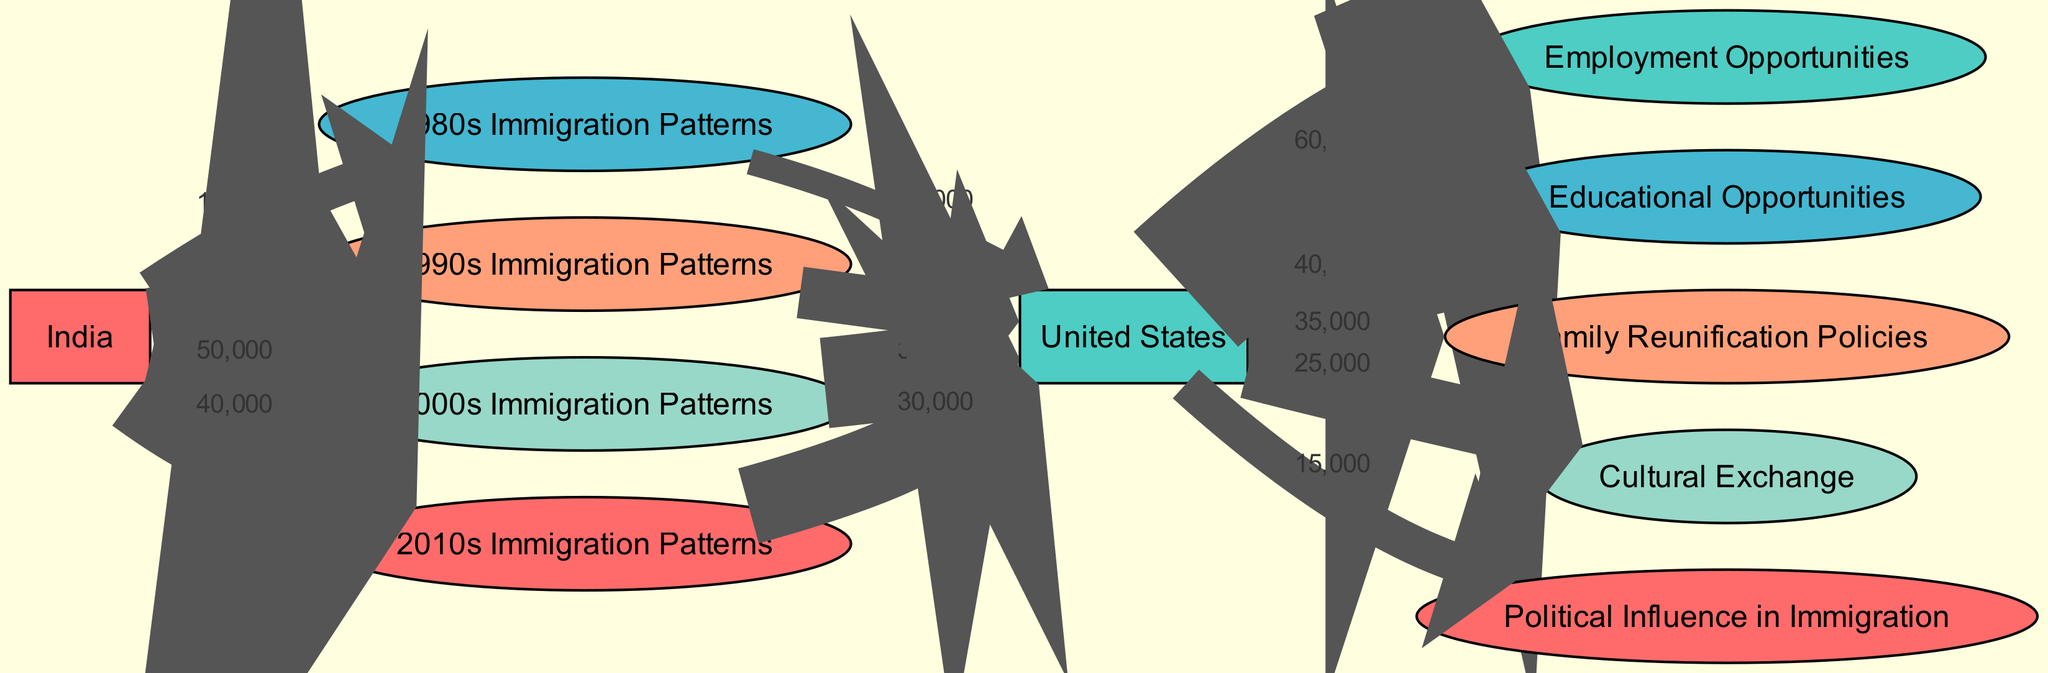What is the total number of immigrants from India in the 1990s? In the diagram, the flow from India to the 1990s Immigration Patterns node shows a value of 30,000. Thus, the total number of immigrants from India during the 1990s is derived directly from this value.
Answer: 30,000 What was the migration flow to the US from the 2000s? The flow from the 2000s Immigration Patterns node to the US node is represented by a value of 35,000. This indicates that 35,000 individuals migrated to the US from the 2000s cohort.
Answer: 35,000 Which immigration pattern had the highest flow to the US? By examining the connections to the US node, the 2000s Immigration Patterns shows a value of 35,000, which is the highest flow compared to the other immigration periods (1980s: 10,000; 1990s: 20,000; 2010s: 30,000).
Answer: 2000s Immigration Patterns What percentage of the total immigration from India in the 2000s successfully settled in the US? To find the percentage, divide the flow from the 2000s Immigration Patterns to the US (35,000) by the original flow from India to this node (50,000). (35,000 / 50,000) * 100 equals 70%. Therefore, 70% of the immigrants from the 2000s settled in the US.
Answer: 70% What were the three main opportunities available for the Sikh community in the US? The diagram shows flows leading to Employment Opportunities (60,000), Educational Opportunities (40,000), and Family Reunification Policies (35,000) from the US node. These are the three main opportunities that can be identified from the flows in the diagram.
Answer: Employment, Education, Family Reunification Which decade had the lowest flow of immigrants to the US? Looking at the flows from each decade to the US, the 1980s Immigration Patterns shows the smallest value of 10,000. Thus, it had the lowest flow of immigrants to the US, compared to all other decades.
Answer: 1980s Immigration Patterns What total flow does Cultural Exchange represent from the US? The diagram indicates that the flow from the US node to Cultural Exchange is 25,000. This indicates that 25,000 individuals participated in cultural exchange activities coming from the US.
Answer: 25,000 What nodes are specifically related to family dynamics in the US migration patterns? The diagram identifies Family Reunification Policies as a key node indicating family dynamics related to migration. It shows a flow of 35,000 from the US node, establishing its direct relevance to family integration following migration.
Answer: Family Reunification Policies 